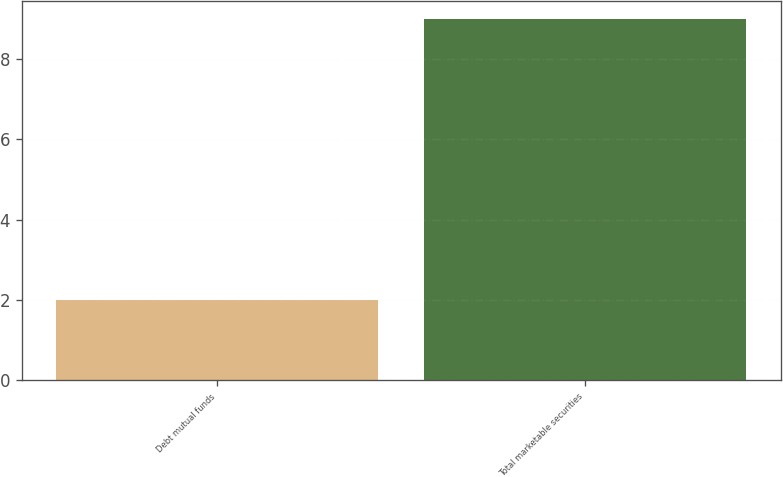<chart> <loc_0><loc_0><loc_500><loc_500><bar_chart><fcel>Debt mutual funds<fcel>Total marketable securities<nl><fcel>2<fcel>9<nl></chart> 